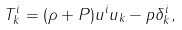Convert formula to latex. <formula><loc_0><loc_0><loc_500><loc_500>T _ { k } ^ { i } = ( \rho + P ) u ^ { i } u _ { k } - p \delta _ { k } ^ { i } ,</formula> 